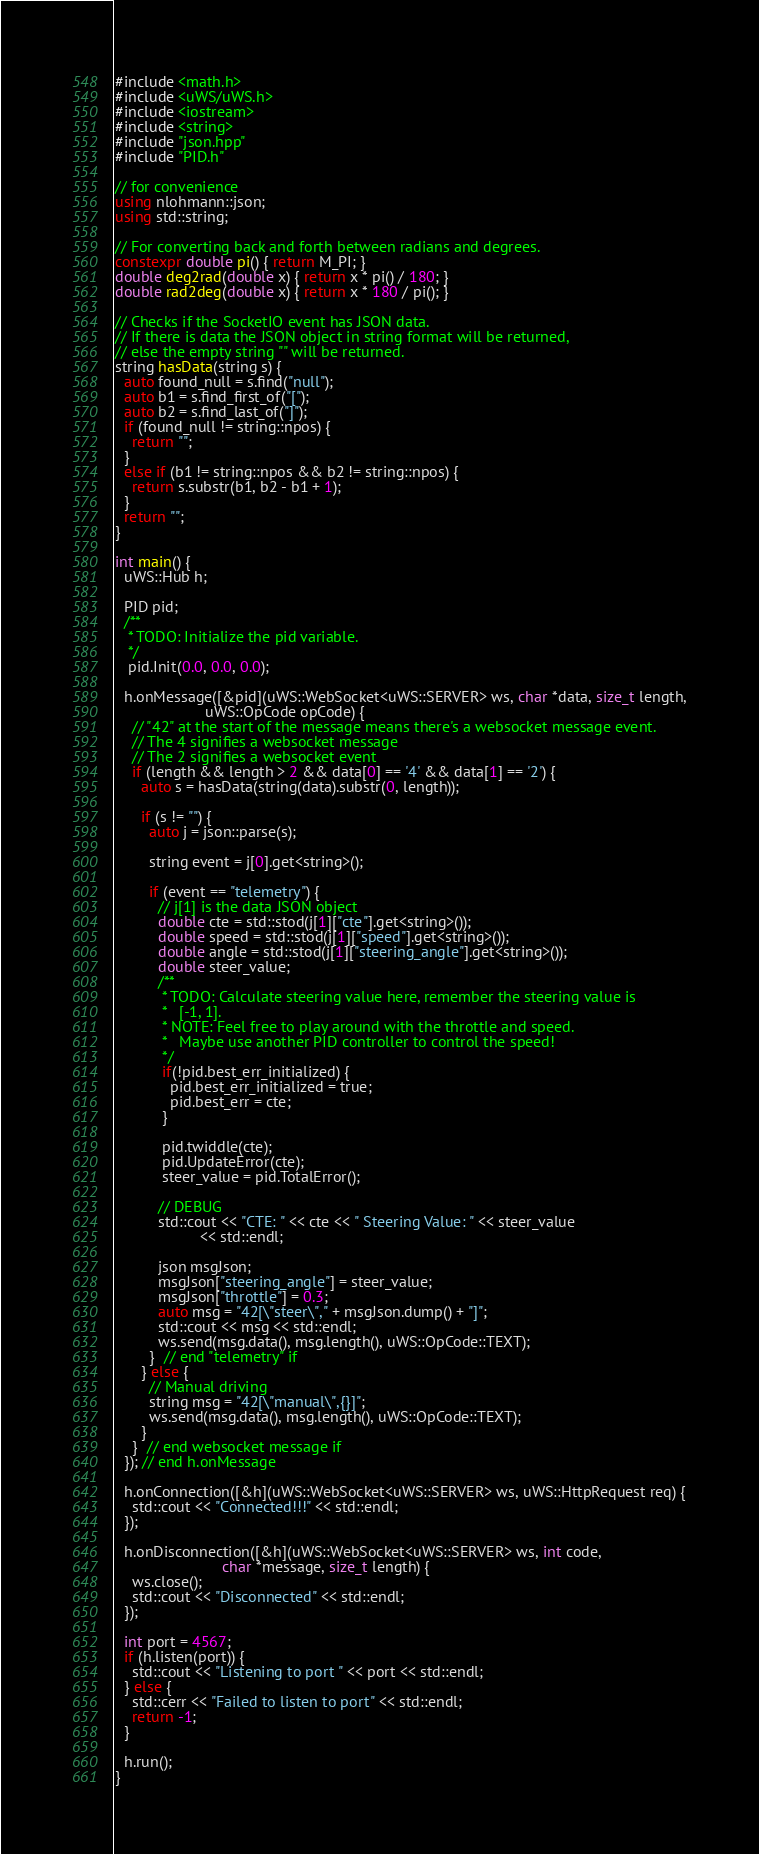Convert code to text. <code><loc_0><loc_0><loc_500><loc_500><_C++_>#include <math.h>
#include <uWS/uWS.h>
#include <iostream>
#include <string>
#include "json.hpp"
#include "PID.h"

// for convenience
using nlohmann::json;
using std::string;

// For converting back and forth between radians and degrees.
constexpr double pi() { return M_PI; }
double deg2rad(double x) { return x * pi() / 180; }
double rad2deg(double x) { return x * 180 / pi(); }

// Checks if the SocketIO event has JSON data.
// If there is data the JSON object in string format will be returned,
// else the empty string "" will be returned.
string hasData(string s) {
  auto found_null = s.find("null");
  auto b1 = s.find_first_of("[");
  auto b2 = s.find_last_of("]");
  if (found_null != string::npos) {
    return "";
  }
  else if (b1 != string::npos && b2 != string::npos) {
    return s.substr(b1, b2 - b1 + 1);
  }
  return "";
}

int main() {
  uWS::Hub h;

  PID pid;
  /**
   * TODO: Initialize the pid variable.
   */
   pid.Init(0.0, 0.0, 0.0);

  h.onMessage([&pid](uWS::WebSocket<uWS::SERVER> ws, char *data, size_t length,
                     uWS::OpCode opCode) {
    // "42" at the start of the message means there's a websocket message event.
    // The 4 signifies a websocket message
    // The 2 signifies a websocket event
    if (length && length > 2 && data[0] == '4' && data[1] == '2') {
      auto s = hasData(string(data).substr(0, length));

      if (s != "") {
        auto j = json::parse(s);

        string event = j[0].get<string>();

        if (event == "telemetry") {
          // j[1] is the data JSON object
          double cte = std::stod(j[1]["cte"].get<string>());
          double speed = std::stod(j[1]["speed"].get<string>());
          double angle = std::stod(j[1]["steering_angle"].get<string>());
          double steer_value;
          /**
           * TODO: Calculate steering value here, remember the steering value is
           *   [-1, 1].
           * NOTE: Feel free to play around with the throttle and speed.
           *   Maybe use another PID controller to control the speed!
           */
           if(!pid.best_err_initialized) {
             pid.best_err_initialized = true;
             pid.best_err = cte;
           }

           pid.twiddle(cte);
           pid.UpdateError(cte);
           steer_value = pid.TotalError();

          // DEBUG
          std::cout << "CTE: " << cte << " Steering Value: " << steer_value
                    << std::endl;

          json msgJson;
          msgJson["steering_angle"] = steer_value;
          msgJson["throttle"] = 0.3;
          auto msg = "42[\"steer\"," + msgJson.dump() + "]";
          std::cout << msg << std::endl;
          ws.send(msg.data(), msg.length(), uWS::OpCode::TEXT);
        }  // end "telemetry" if
      } else {
        // Manual driving
        string msg = "42[\"manual\",{}]";
        ws.send(msg.data(), msg.length(), uWS::OpCode::TEXT);
      }
    }  // end websocket message if
  }); // end h.onMessage

  h.onConnection([&h](uWS::WebSocket<uWS::SERVER> ws, uWS::HttpRequest req) {
    std::cout << "Connected!!!" << std::endl;
  });

  h.onDisconnection([&h](uWS::WebSocket<uWS::SERVER> ws, int code,
                         char *message, size_t length) {
    ws.close();
    std::cout << "Disconnected" << std::endl;
  });

  int port = 4567;
  if (h.listen(port)) {
    std::cout << "Listening to port " << port << std::endl;
  } else {
    std::cerr << "Failed to listen to port" << std::endl;
    return -1;
  }

  h.run();
}</code> 